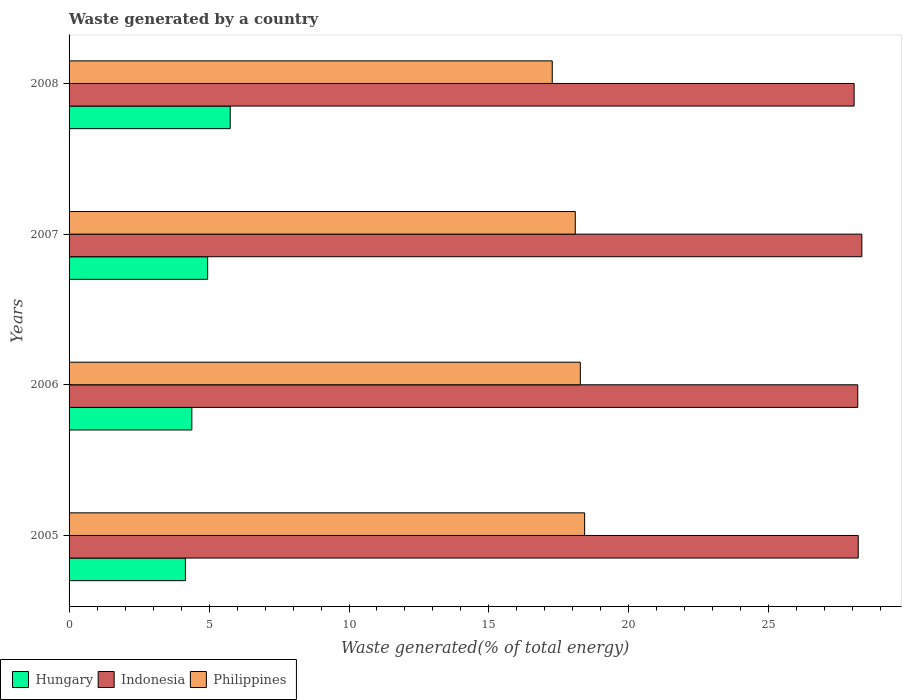How many different coloured bars are there?
Your response must be concise. 3. Are the number of bars per tick equal to the number of legend labels?
Your answer should be compact. Yes. Are the number of bars on each tick of the Y-axis equal?
Keep it short and to the point. Yes. How many bars are there on the 2nd tick from the top?
Your answer should be compact. 3. In how many cases, is the number of bars for a given year not equal to the number of legend labels?
Your response must be concise. 0. What is the total waste generated in Hungary in 2005?
Provide a short and direct response. 4.16. Across all years, what is the maximum total waste generated in Indonesia?
Offer a terse response. 28.32. Across all years, what is the minimum total waste generated in Philippines?
Ensure brevity in your answer.  17.26. In which year was the total waste generated in Philippines minimum?
Offer a terse response. 2008. What is the total total waste generated in Indonesia in the graph?
Offer a very short reply. 112.73. What is the difference between the total waste generated in Hungary in 2005 and that in 2008?
Make the answer very short. -1.6. What is the difference between the total waste generated in Hungary in 2008 and the total waste generated in Philippines in 2007?
Ensure brevity in your answer.  -12.33. What is the average total waste generated in Hungary per year?
Provide a succinct answer. 4.81. In the year 2007, what is the difference between the total waste generated in Hungary and total waste generated in Philippines?
Offer a very short reply. -13.13. What is the ratio of the total waste generated in Philippines in 2006 to that in 2008?
Give a very brief answer. 1.06. What is the difference between the highest and the second highest total waste generated in Indonesia?
Provide a succinct answer. 0.13. What is the difference between the highest and the lowest total waste generated in Philippines?
Keep it short and to the point. 1.16. In how many years, is the total waste generated in Philippines greater than the average total waste generated in Philippines taken over all years?
Provide a short and direct response. 3. Is the sum of the total waste generated in Philippines in 2005 and 2007 greater than the maximum total waste generated in Indonesia across all years?
Provide a short and direct response. Yes. What does the 1st bar from the top in 2008 represents?
Provide a succinct answer. Philippines. Is it the case that in every year, the sum of the total waste generated in Hungary and total waste generated in Indonesia is greater than the total waste generated in Philippines?
Ensure brevity in your answer.  Yes. Does the graph contain grids?
Ensure brevity in your answer.  No. Where does the legend appear in the graph?
Offer a terse response. Bottom left. How are the legend labels stacked?
Give a very brief answer. Horizontal. What is the title of the graph?
Make the answer very short. Waste generated by a country. What is the label or title of the X-axis?
Make the answer very short. Waste generated(% of total energy). What is the Waste generated(% of total energy) in Hungary in 2005?
Your answer should be very brief. 4.16. What is the Waste generated(% of total energy) in Indonesia in 2005?
Offer a terse response. 28.19. What is the Waste generated(% of total energy) of Philippines in 2005?
Provide a short and direct response. 18.42. What is the Waste generated(% of total energy) in Hungary in 2006?
Ensure brevity in your answer.  4.39. What is the Waste generated(% of total energy) of Indonesia in 2006?
Keep it short and to the point. 28.17. What is the Waste generated(% of total energy) in Philippines in 2006?
Your answer should be very brief. 18.26. What is the Waste generated(% of total energy) of Hungary in 2007?
Offer a terse response. 4.95. What is the Waste generated(% of total energy) of Indonesia in 2007?
Your answer should be compact. 28.32. What is the Waste generated(% of total energy) in Philippines in 2007?
Your answer should be compact. 18.08. What is the Waste generated(% of total energy) in Hungary in 2008?
Offer a very short reply. 5.76. What is the Waste generated(% of total energy) in Indonesia in 2008?
Ensure brevity in your answer.  28.04. What is the Waste generated(% of total energy) in Philippines in 2008?
Make the answer very short. 17.26. Across all years, what is the maximum Waste generated(% of total energy) of Hungary?
Your answer should be very brief. 5.76. Across all years, what is the maximum Waste generated(% of total energy) in Indonesia?
Offer a very short reply. 28.32. Across all years, what is the maximum Waste generated(% of total energy) in Philippines?
Your answer should be very brief. 18.42. Across all years, what is the minimum Waste generated(% of total energy) in Hungary?
Your answer should be very brief. 4.16. Across all years, what is the minimum Waste generated(% of total energy) of Indonesia?
Offer a terse response. 28.04. Across all years, what is the minimum Waste generated(% of total energy) of Philippines?
Give a very brief answer. 17.26. What is the total Waste generated(% of total energy) of Hungary in the graph?
Keep it short and to the point. 19.25. What is the total Waste generated(% of total energy) of Indonesia in the graph?
Offer a very short reply. 112.73. What is the total Waste generated(% of total energy) in Philippines in the graph?
Make the answer very short. 72.03. What is the difference between the Waste generated(% of total energy) in Hungary in 2005 and that in 2006?
Ensure brevity in your answer.  -0.23. What is the difference between the Waste generated(% of total energy) in Indonesia in 2005 and that in 2006?
Ensure brevity in your answer.  0.02. What is the difference between the Waste generated(% of total energy) of Philippines in 2005 and that in 2006?
Your response must be concise. 0.15. What is the difference between the Waste generated(% of total energy) in Hungary in 2005 and that in 2007?
Offer a very short reply. -0.8. What is the difference between the Waste generated(% of total energy) in Indonesia in 2005 and that in 2007?
Keep it short and to the point. -0.13. What is the difference between the Waste generated(% of total energy) of Philippines in 2005 and that in 2007?
Your answer should be very brief. 0.33. What is the difference between the Waste generated(% of total energy) of Hungary in 2005 and that in 2008?
Offer a very short reply. -1.6. What is the difference between the Waste generated(% of total energy) in Indonesia in 2005 and that in 2008?
Offer a very short reply. 0.15. What is the difference between the Waste generated(% of total energy) of Philippines in 2005 and that in 2008?
Offer a terse response. 1.16. What is the difference between the Waste generated(% of total energy) of Hungary in 2006 and that in 2007?
Keep it short and to the point. -0.57. What is the difference between the Waste generated(% of total energy) of Indonesia in 2006 and that in 2007?
Provide a succinct answer. -0.15. What is the difference between the Waste generated(% of total energy) of Philippines in 2006 and that in 2007?
Provide a short and direct response. 0.18. What is the difference between the Waste generated(% of total energy) of Hungary in 2006 and that in 2008?
Ensure brevity in your answer.  -1.37. What is the difference between the Waste generated(% of total energy) in Indonesia in 2006 and that in 2008?
Offer a very short reply. 0.13. What is the difference between the Waste generated(% of total energy) in Hungary in 2007 and that in 2008?
Your answer should be very brief. -0.81. What is the difference between the Waste generated(% of total energy) in Indonesia in 2007 and that in 2008?
Offer a very short reply. 0.28. What is the difference between the Waste generated(% of total energy) in Philippines in 2007 and that in 2008?
Give a very brief answer. 0.82. What is the difference between the Waste generated(% of total energy) in Hungary in 2005 and the Waste generated(% of total energy) in Indonesia in 2006?
Offer a very short reply. -24.02. What is the difference between the Waste generated(% of total energy) of Hungary in 2005 and the Waste generated(% of total energy) of Philippines in 2006?
Your answer should be compact. -14.11. What is the difference between the Waste generated(% of total energy) of Indonesia in 2005 and the Waste generated(% of total energy) of Philippines in 2006?
Give a very brief answer. 9.93. What is the difference between the Waste generated(% of total energy) of Hungary in 2005 and the Waste generated(% of total energy) of Indonesia in 2007?
Provide a succinct answer. -24.17. What is the difference between the Waste generated(% of total energy) of Hungary in 2005 and the Waste generated(% of total energy) of Philippines in 2007?
Your response must be concise. -13.93. What is the difference between the Waste generated(% of total energy) of Indonesia in 2005 and the Waste generated(% of total energy) of Philippines in 2007?
Make the answer very short. 10.11. What is the difference between the Waste generated(% of total energy) of Hungary in 2005 and the Waste generated(% of total energy) of Indonesia in 2008?
Ensure brevity in your answer.  -23.89. What is the difference between the Waste generated(% of total energy) of Hungary in 2005 and the Waste generated(% of total energy) of Philippines in 2008?
Your response must be concise. -13.11. What is the difference between the Waste generated(% of total energy) of Indonesia in 2005 and the Waste generated(% of total energy) of Philippines in 2008?
Your response must be concise. 10.93. What is the difference between the Waste generated(% of total energy) in Hungary in 2006 and the Waste generated(% of total energy) in Indonesia in 2007?
Offer a terse response. -23.94. What is the difference between the Waste generated(% of total energy) in Hungary in 2006 and the Waste generated(% of total energy) in Philippines in 2007?
Give a very brief answer. -13.7. What is the difference between the Waste generated(% of total energy) in Indonesia in 2006 and the Waste generated(% of total energy) in Philippines in 2007?
Provide a short and direct response. 10.09. What is the difference between the Waste generated(% of total energy) of Hungary in 2006 and the Waste generated(% of total energy) of Indonesia in 2008?
Make the answer very short. -23.66. What is the difference between the Waste generated(% of total energy) in Hungary in 2006 and the Waste generated(% of total energy) in Philippines in 2008?
Offer a very short reply. -12.88. What is the difference between the Waste generated(% of total energy) of Indonesia in 2006 and the Waste generated(% of total energy) of Philippines in 2008?
Offer a terse response. 10.91. What is the difference between the Waste generated(% of total energy) of Hungary in 2007 and the Waste generated(% of total energy) of Indonesia in 2008?
Make the answer very short. -23.09. What is the difference between the Waste generated(% of total energy) of Hungary in 2007 and the Waste generated(% of total energy) of Philippines in 2008?
Your answer should be compact. -12.31. What is the difference between the Waste generated(% of total energy) of Indonesia in 2007 and the Waste generated(% of total energy) of Philippines in 2008?
Your answer should be compact. 11.06. What is the average Waste generated(% of total energy) of Hungary per year?
Your answer should be very brief. 4.81. What is the average Waste generated(% of total energy) in Indonesia per year?
Make the answer very short. 28.18. What is the average Waste generated(% of total energy) of Philippines per year?
Keep it short and to the point. 18.01. In the year 2005, what is the difference between the Waste generated(% of total energy) of Hungary and Waste generated(% of total energy) of Indonesia?
Your answer should be compact. -24.04. In the year 2005, what is the difference between the Waste generated(% of total energy) in Hungary and Waste generated(% of total energy) in Philippines?
Offer a terse response. -14.26. In the year 2005, what is the difference between the Waste generated(% of total energy) in Indonesia and Waste generated(% of total energy) in Philippines?
Offer a terse response. 9.77. In the year 2006, what is the difference between the Waste generated(% of total energy) in Hungary and Waste generated(% of total energy) in Indonesia?
Your answer should be compact. -23.79. In the year 2006, what is the difference between the Waste generated(% of total energy) in Hungary and Waste generated(% of total energy) in Philippines?
Your answer should be compact. -13.88. In the year 2006, what is the difference between the Waste generated(% of total energy) of Indonesia and Waste generated(% of total energy) of Philippines?
Make the answer very short. 9.91. In the year 2007, what is the difference between the Waste generated(% of total energy) of Hungary and Waste generated(% of total energy) of Indonesia?
Offer a terse response. -23.37. In the year 2007, what is the difference between the Waste generated(% of total energy) of Hungary and Waste generated(% of total energy) of Philippines?
Offer a terse response. -13.13. In the year 2007, what is the difference between the Waste generated(% of total energy) in Indonesia and Waste generated(% of total energy) in Philippines?
Your answer should be compact. 10.24. In the year 2008, what is the difference between the Waste generated(% of total energy) of Hungary and Waste generated(% of total energy) of Indonesia?
Ensure brevity in your answer.  -22.29. In the year 2008, what is the difference between the Waste generated(% of total energy) in Hungary and Waste generated(% of total energy) in Philippines?
Your response must be concise. -11.5. In the year 2008, what is the difference between the Waste generated(% of total energy) of Indonesia and Waste generated(% of total energy) of Philippines?
Your response must be concise. 10.78. What is the ratio of the Waste generated(% of total energy) of Hungary in 2005 to that in 2006?
Give a very brief answer. 0.95. What is the ratio of the Waste generated(% of total energy) in Indonesia in 2005 to that in 2006?
Offer a terse response. 1. What is the ratio of the Waste generated(% of total energy) of Philippines in 2005 to that in 2006?
Ensure brevity in your answer.  1.01. What is the ratio of the Waste generated(% of total energy) of Hungary in 2005 to that in 2007?
Offer a very short reply. 0.84. What is the ratio of the Waste generated(% of total energy) of Indonesia in 2005 to that in 2007?
Your answer should be very brief. 1. What is the ratio of the Waste generated(% of total energy) in Philippines in 2005 to that in 2007?
Provide a succinct answer. 1.02. What is the ratio of the Waste generated(% of total energy) of Hungary in 2005 to that in 2008?
Your answer should be very brief. 0.72. What is the ratio of the Waste generated(% of total energy) of Indonesia in 2005 to that in 2008?
Your answer should be compact. 1.01. What is the ratio of the Waste generated(% of total energy) of Philippines in 2005 to that in 2008?
Your answer should be compact. 1.07. What is the ratio of the Waste generated(% of total energy) of Hungary in 2006 to that in 2007?
Your response must be concise. 0.89. What is the ratio of the Waste generated(% of total energy) in Indonesia in 2006 to that in 2007?
Provide a short and direct response. 0.99. What is the ratio of the Waste generated(% of total energy) of Philippines in 2006 to that in 2007?
Give a very brief answer. 1.01. What is the ratio of the Waste generated(% of total energy) of Hungary in 2006 to that in 2008?
Your answer should be compact. 0.76. What is the ratio of the Waste generated(% of total energy) of Indonesia in 2006 to that in 2008?
Your answer should be compact. 1. What is the ratio of the Waste generated(% of total energy) of Philippines in 2006 to that in 2008?
Give a very brief answer. 1.06. What is the ratio of the Waste generated(% of total energy) in Hungary in 2007 to that in 2008?
Offer a very short reply. 0.86. What is the ratio of the Waste generated(% of total energy) in Indonesia in 2007 to that in 2008?
Provide a short and direct response. 1.01. What is the ratio of the Waste generated(% of total energy) of Philippines in 2007 to that in 2008?
Offer a terse response. 1.05. What is the difference between the highest and the second highest Waste generated(% of total energy) in Hungary?
Provide a succinct answer. 0.81. What is the difference between the highest and the second highest Waste generated(% of total energy) of Indonesia?
Your response must be concise. 0.13. What is the difference between the highest and the second highest Waste generated(% of total energy) of Philippines?
Give a very brief answer. 0.15. What is the difference between the highest and the lowest Waste generated(% of total energy) in Hungary?
Provide a short and direct response. 1.6. What is the difference between the highest and the lowest Waste generated(% of total energy) in Indonesia?
Make the answer very short. 0.28. What is the difference between the highest and the lowest Waste generated(% of total energy) of Philippines?
Provide a succinct answer. 1.16. 